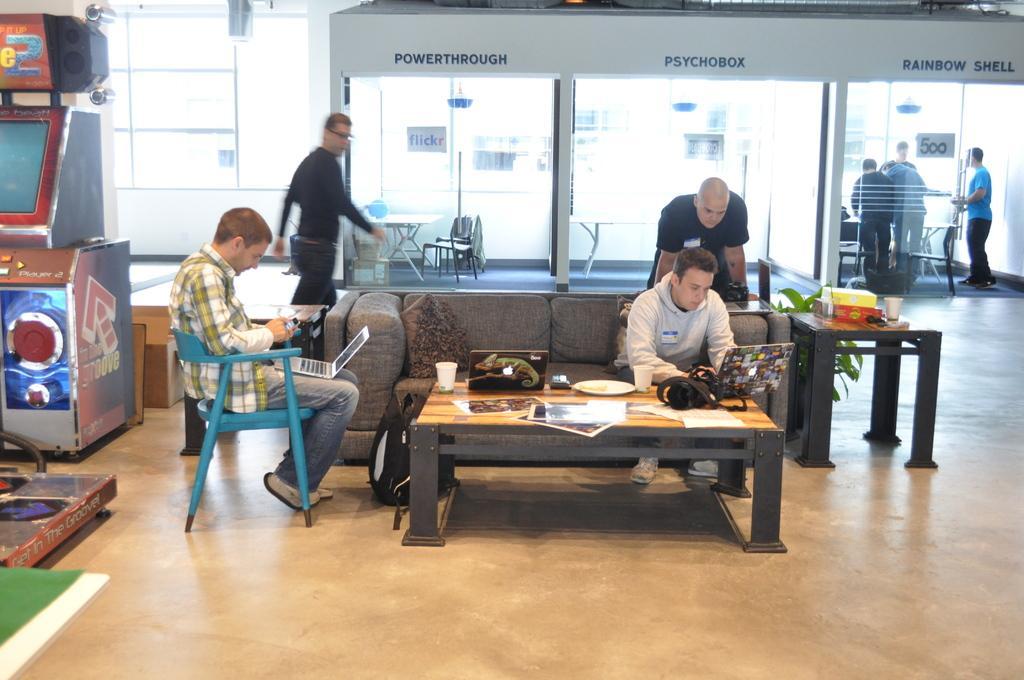In one or two sentences, can you explain what this image depicts? There is a room with a gaming machine. A man is sitting on a blue chair , on his lap there is a laptop. He is looking at his phone which is in his hand. He is wearing a checked shirt. There is a sofa in the middle of the room. On the sofa a person is sitting. He is looking at his laptop. There is a table in front of the sofa. On the table there is laptop , camera, plate ,cup, paper. There is bag on the floor. A man is standing beside the person who is sitting on the sofa. He is looking at the laptop. He a bald headed. There is plant beside him. There is a side table beside the sofa. There is a glass on the side table. A person is walking by looking at the other person. There are the glasses. These is the glass wall inside it there is table, chairs,there is card, there some cartons. Some people are standing over here. This is written reinforce ,cell ,power through , psycho box, 500. The man is wearing white shoes. There is a lizard in the cover of this laptop. There are few cartons behind the gaming machine. 